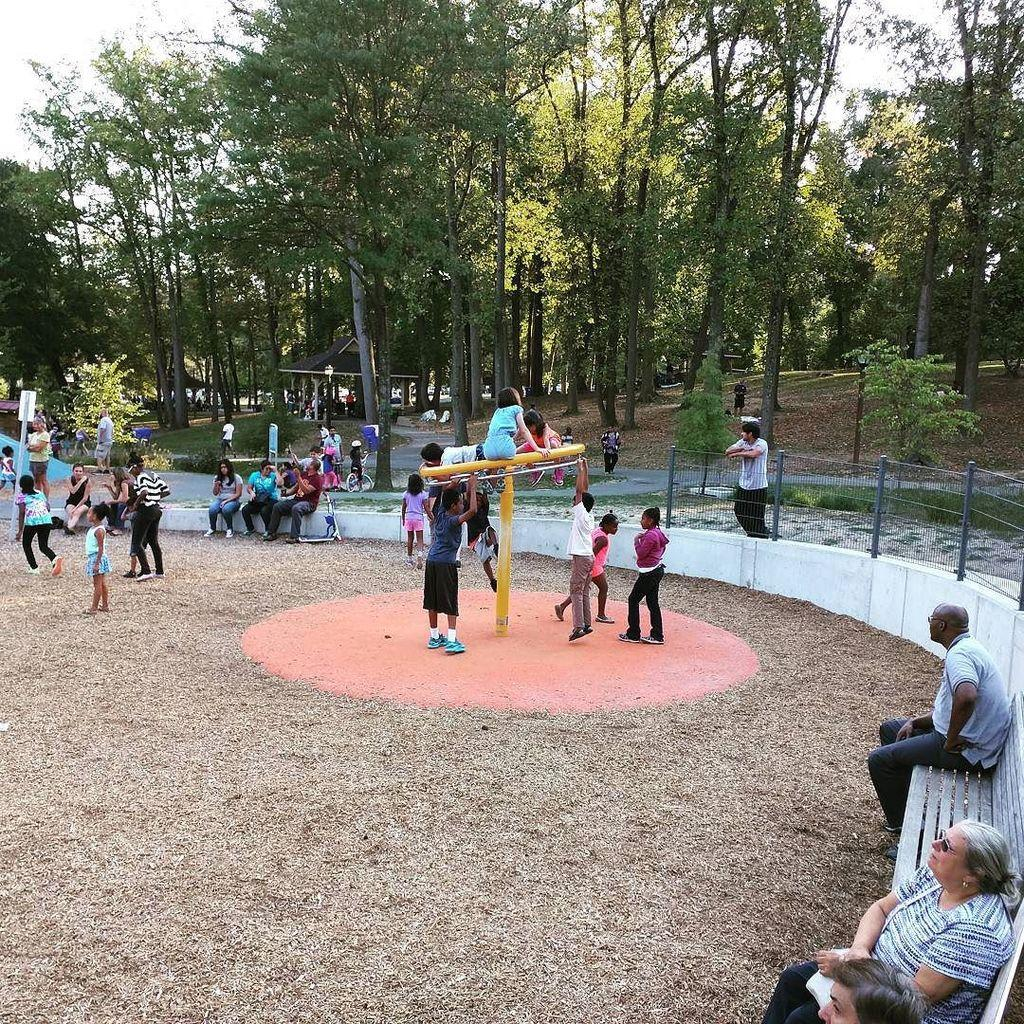What are the people in the image doing? There are people standing and sitting on a bench in the image. Can you describe the trees in the image? The trees in the image have green leaves. How many people are sitting on the bench? The image shows people sitting on a bench, but the exact number cannot be determined from the provided facts. What type of pet is the writer holding in the image? There is no writer or pet present in the image. 